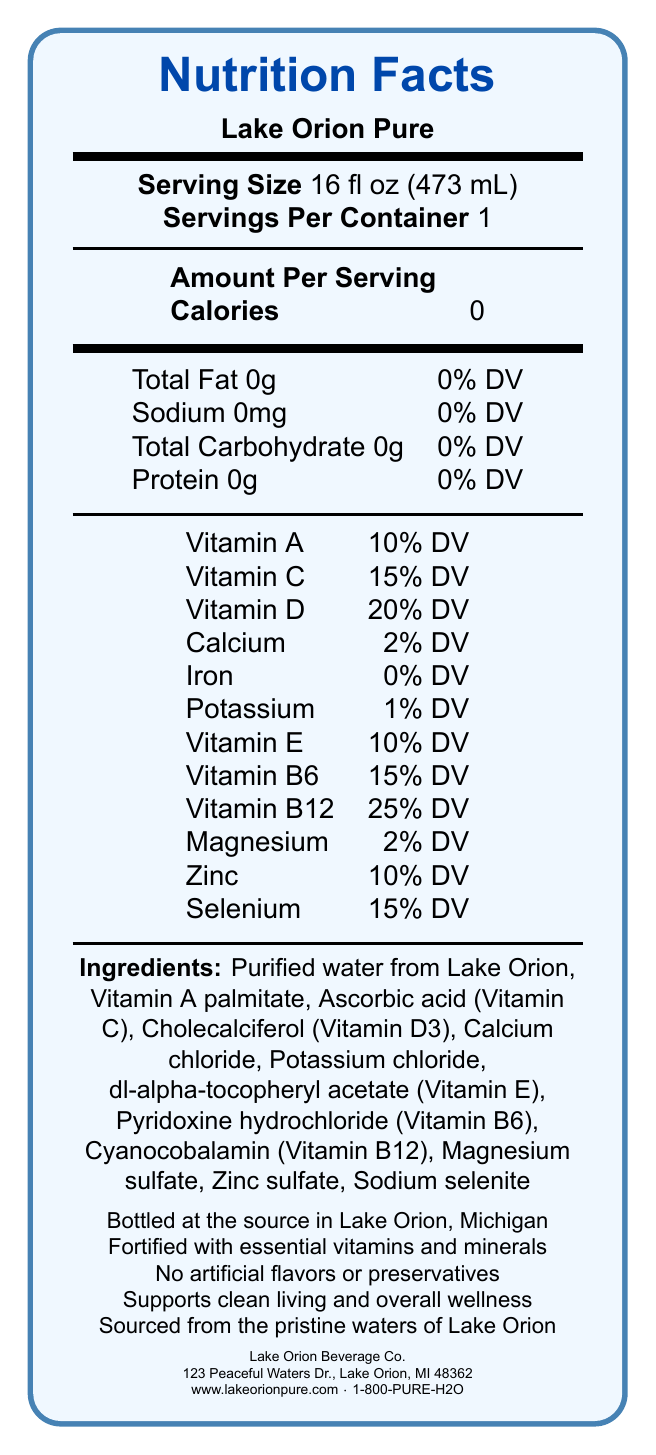What is the serving size of Lake Orion Pure? The document specifies the serving size as 16 fl oz (473 mL).
Answer: 16 fl oz (473 mL) How many calories are in one serving of Lake Orion Pure? The document states that there are 0 calories per serving.
Answer: 0 Which vitamins are present in Lake Orion Pure? The document lists these vitamins and their daily value percentages under the nutrition facts.
Answer: Vitamin A, Vitamin C, Vitamin D, Vitamin E, Vitamin B6, Vitamin B12 What percentage of Vitamin D does Lake Orion Pure provide per serving? The document indicates that Vitamin D is present at 20% of the daily value per serving.
Answer: 20% DV Who is the manufacturer of Lake Orion Pure? The document mentions that Lake Orion Beverage Co. is the manufacturer.
Answer: Lake Orion Beverage Co. Which of the following minerals are included in Lake Orion Pure? A. Iron B. Magnesium C. Zinc D. Sodium The nutrition facts label lists Magnesium and Zinc among the included minerals, while Iron and Sodium are either absent or listed with 0%.
Answer: B and C How many grams of protein are there in one serving? A. 0 B. 0.5 C. 1 The nutrition facts label states there are 0 grams of protein per serving.
Answer: A Where is Lake Orion Pure bottled? The document states that Lake Orion Pure is bottled at the source in Lake Orion, Michigan.
Answer: Lake Orion, Michigan Does Lake Orion Pure contain any artificial flavors or preservatives? The document explicitly mentions that there are no artificial flavors or preservatives.
Answer: No What's the address of the manufacturer of Lake Orion Pure? The document lists this address under the manufacturer's information.
Answer: 123 Peaceful Waters Dr., Lake Orion, MI 48362 Can I determine the source of the purified water used in Lake Orion Pure? The document mentions that the water is sourced from Lake Orion.
Answer: Yes Is there any iron in Lake Orion Pure? The document shows Iron as 0% DV in the nutrition facts label.
Answer: No Summarize the main focus of the document. The document contains comprehensive information on the nutritional content and origin of Lake Orion Pure bottled water, emphasizing its clean and fortified nature.
Answer: The document provides detailed nutrition facts for Lake Orion Pure, a vitamin-fortified bottled water sourced from Lake Orion, Michigan. It highlights the serving size, calories, vitamins, and minerals included, along with additional information regarding its manufacturing and purity assurances. Does the document provide any information on price? The document does not provide any information regarding the price of Lake Orion Pure.
Answer: Cannot be determined 